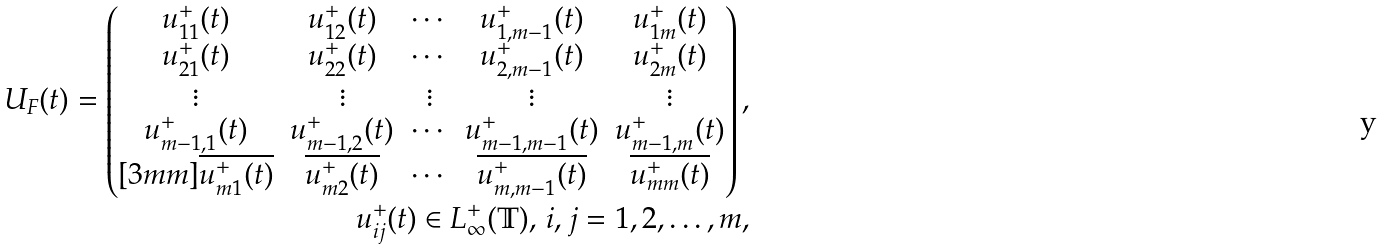Convert formula to latex. <formula><loc_0><loc_0><loc_500><loc_500>U _ { F } ( t ) = \begin{pmatrix} u ^ { + } _ { 1 1 } ( t ) & u ^ { + } _ { 1 2 } ( t ) & \cdots & u ^ { + } _ { 1 , m - 1 } ( t ) & u ^ { + } _ { 1 m } ( t ) \\ u ^ { + } _ { 2 1 } ( t ) & u ^ { + } _ { 2 2 } ( t ) & \cdots & u ^ { + } _ { 2 , m - 1 } ( t ) & u ^ { + } _ { 2 m } ( t ) \\ \vdots & \vdots & \vdots & \vdots & \vdots \\ u ^ { + } _ { m - 1 , 1 } ( t ) & u ^ { + } _ { m - 1 , 2 } ( t ) & \cdots & u ^ { + } _ { m - 1 , m - 1 } ( t ) & u ^ { + } _ { m - 1 , m } ( t ) \\ [ 3 m m ] \overline { u ^ { + } _ { m 1 } ( t ) } & \overline { u ^ { + } _ { m 2 } ( t ) } & \cdots & \overline { u ^ { + } _ { m , m - 1 } ( t ) } & \overline { u ^ { + } _ { m m } ( t ) } \\ \end{pmatrix} , \\ u ^ { + } _ { i j } ( t ) \in L _ { \infty } ^ { + } ( { \mathbb { T } } ) , \, i , j = 1 , 2 , \dots , m ,</formula> 